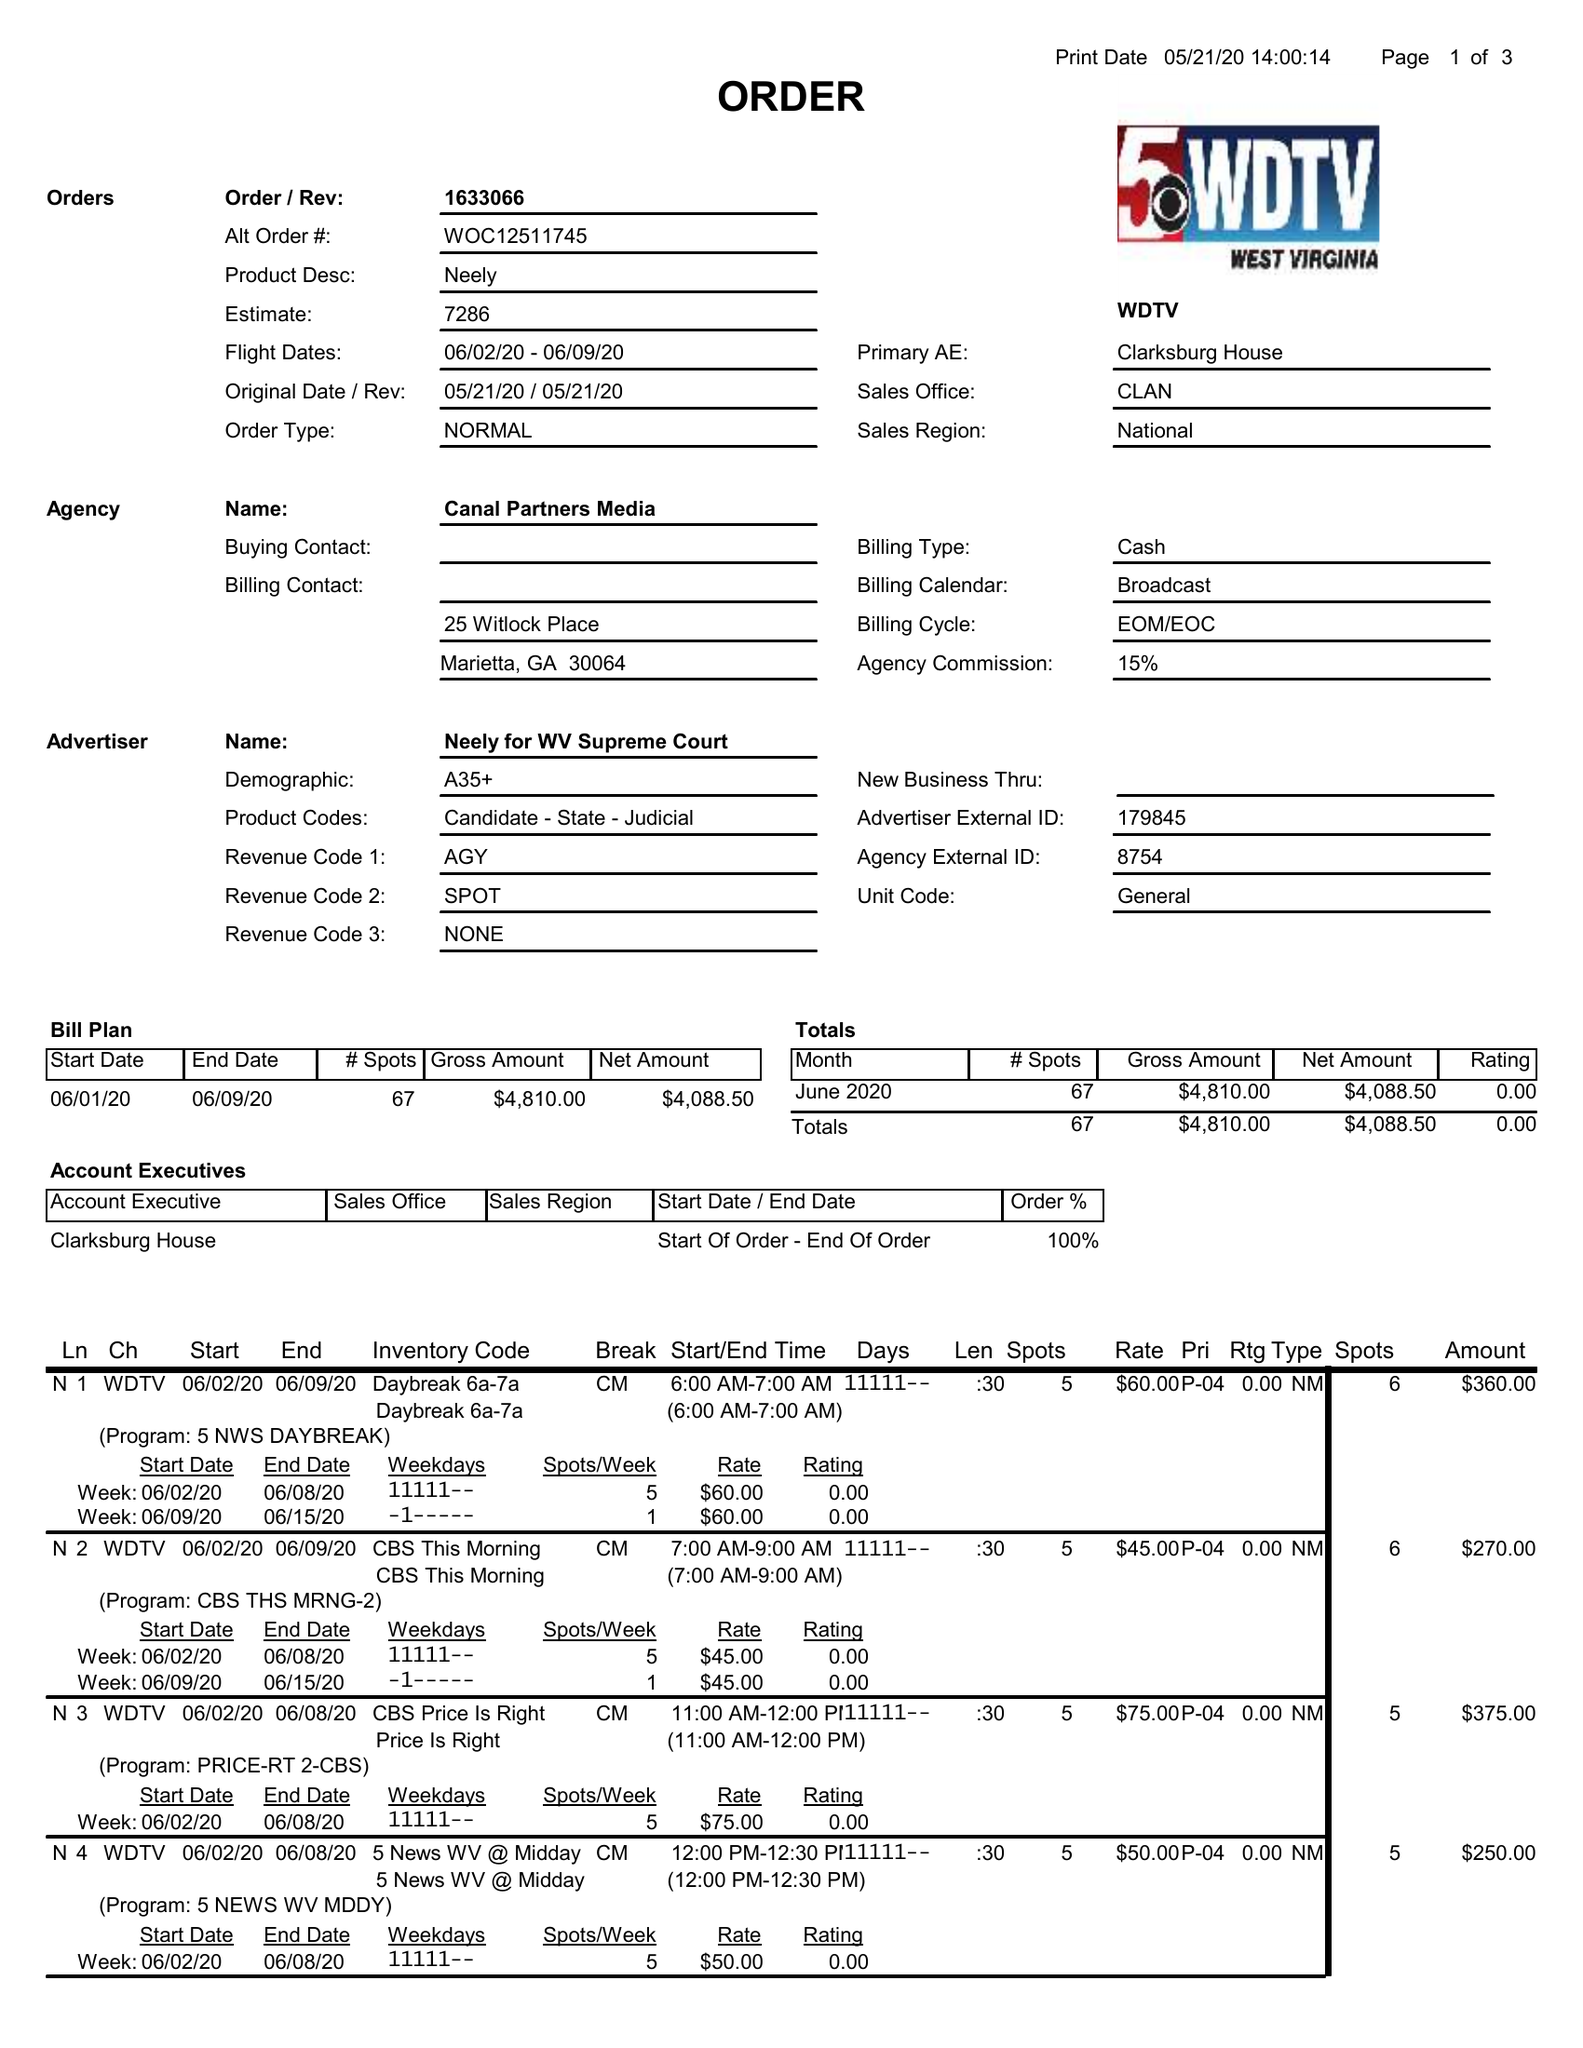What is the value for the gross_amount?
Answer the question using a single word or phrase. 4810.00 